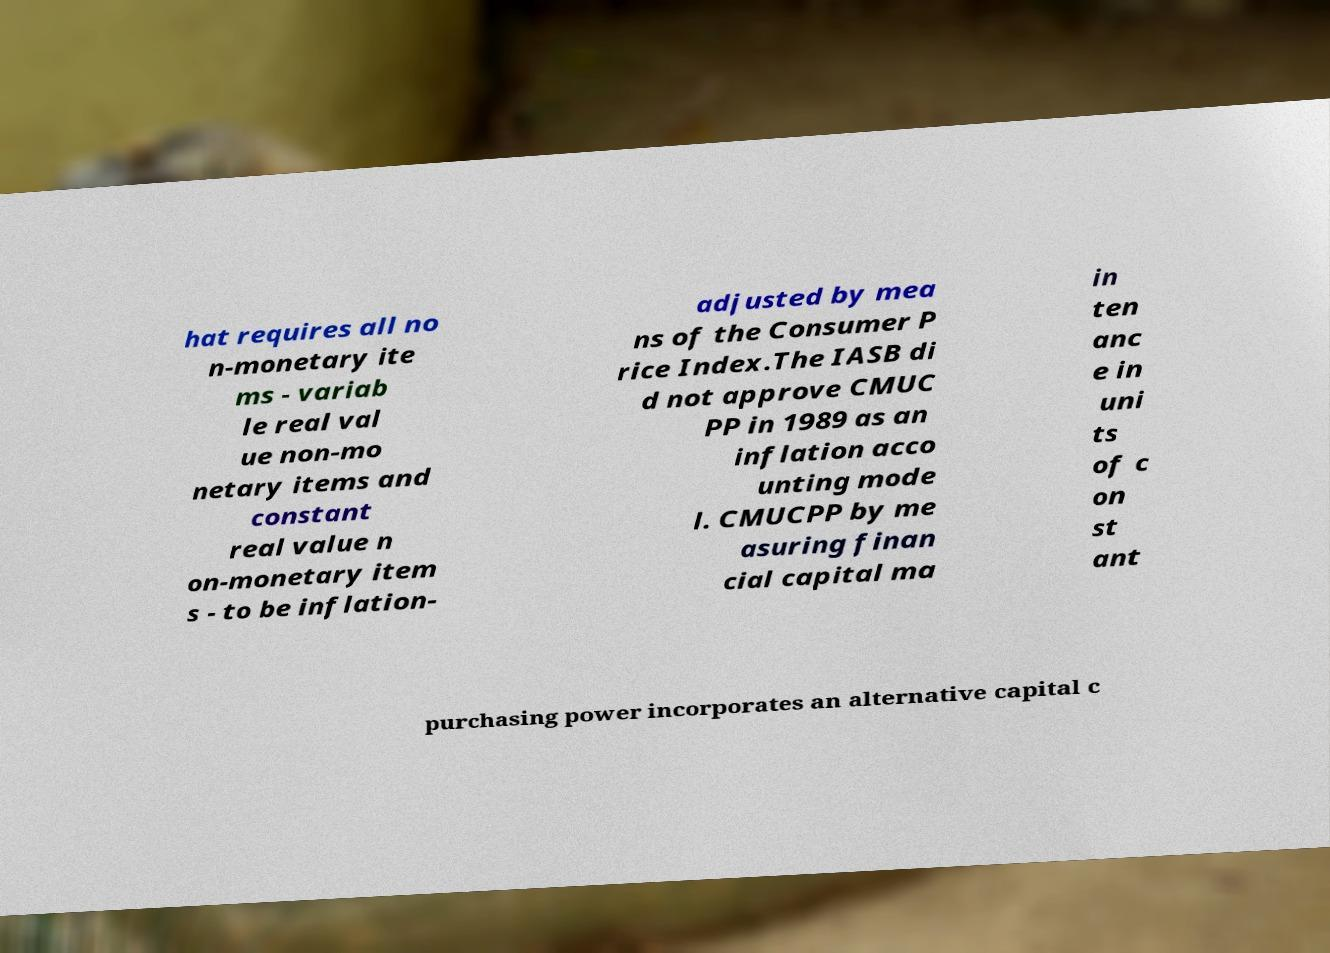For documentation purposes, I need the text within this image transcribed. Could you provide that? hat requires all no n-monetary ite ms - variab le real val ue non-mo netary items and constant real value n on-monetary item s - to be inflation- adjusted by mea ns of the Consumer P rice Index.The IASB di d not approve CMUC PP in 1989 as an inflation acco unting mode l. CMUCPP by me asuring finan cial capital ma in ten anc e in uni ts of c on st ant purchasing power incorporates an alternative capital c 